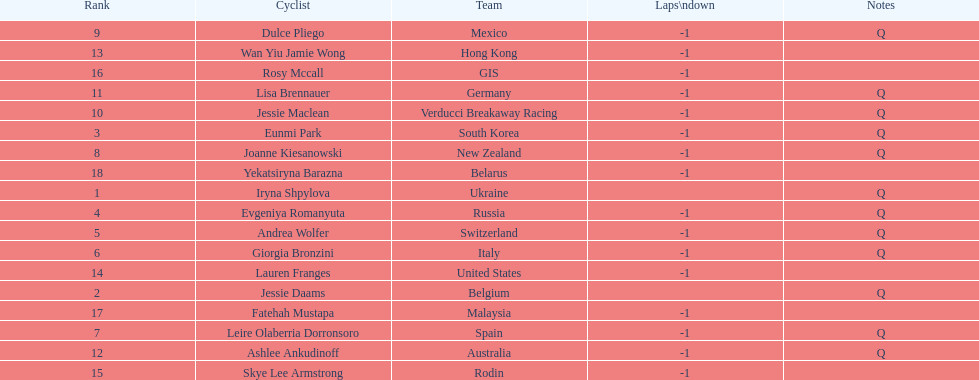How many cyclist do not have -1 laps down? 2. 